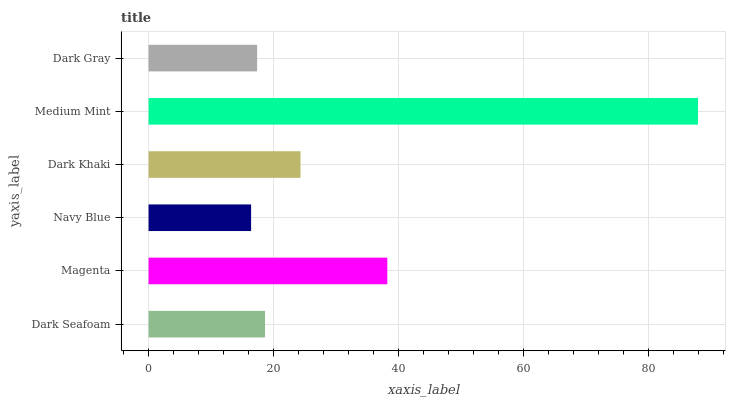Is Navy Blue the minimum?
Answer yes or no. Yes. Is Medium Mint the maximum?
Answer yes or no. Yes. Is Magenta the minimum?
Answer yes or no. No. Is Magenta the maximum?
Answer yes or no. No. Is Magenta greater than Dark Seafoam?
Answer yes or no. Yes. Is Dark Seafoam less than Magenta?
Answer yes or no. Yes. Is Dark Seafoam greater than Magenta?
Answer yes or no. No. Is Magenta less than Dark Seafoam?
Answer yes or no. No. Is Dark Khaki the high median?
Answer yes or no. Yes. Is Dark Seafoam the low median?
Answer yes or no. Yes. Is Dark Seafoam the high median?
Answer yes or no. No. Is Navy Blue the low median?
Answer yes or no. No. 